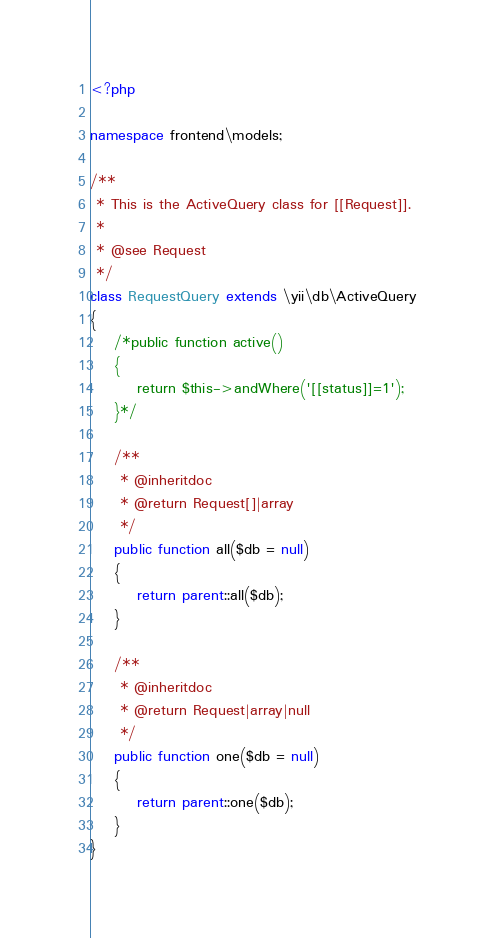Convert code to text. <code><loc_0><loc_0><loc_500><loc_500><_PHP_><?php

namespace frontend\models;

/**
 * This is the ActiveQuery class for [[Request]].
 *
 * @see Request
 */
class RequestQuery extends \yii\db\ActiveQuery
{
    /*public function active()
    {
        return $this->andWhere('[[status]]=1');
    }*/

    /**
     * @inheritdoc
     * @return Request[]|array
     */
    public function all($db = null)
    {
        return parent::all($db);
    }

    /**
     * @inheritdoc
     * @return Request|array|null
     */
    public function one($db = null)
    {
        return parent::one($db);
    }
}
</code> 